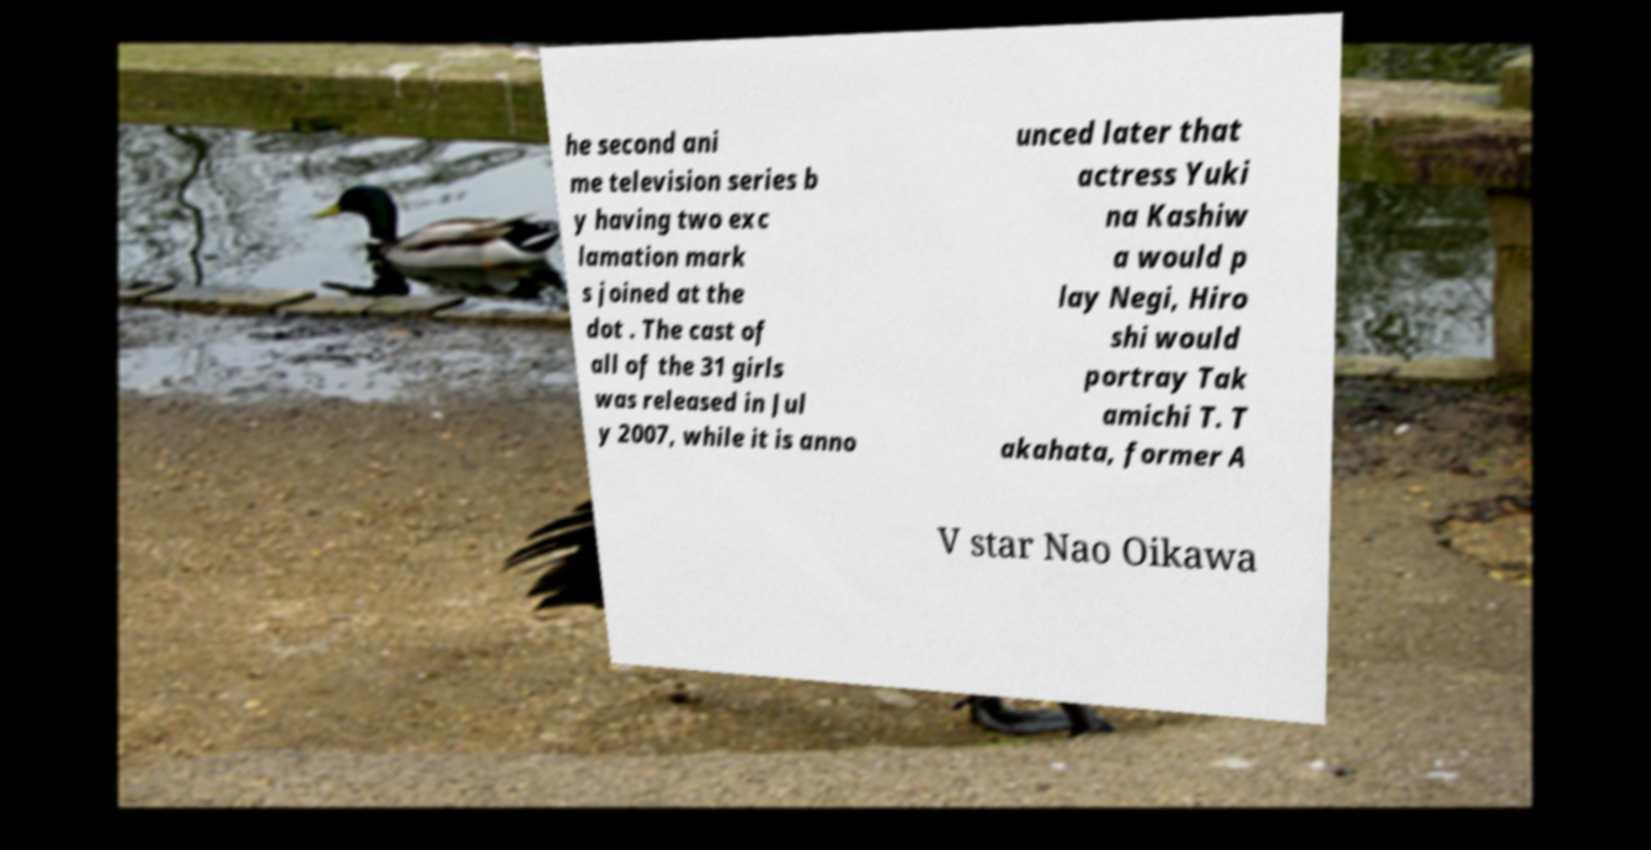Could you extract and type out the text from this image? he second ani me television series b y having two exc lamation mark s joined at the dot . The cast of all of the 31 girls was released in Jul y 2007, while it is anno unced later that actress Yuki na Kashiw a would p lay Negi, Hiro shi would portray Tak amichi T. T akahata, former A V star Nao Oikawa 